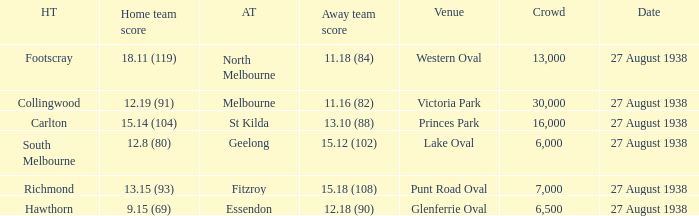Which away team scored 12.18 (90)? Essendon. 